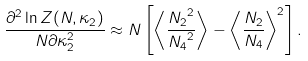Convert formula to latex. <formula><loc_0><loc_0><loc_500><loc_500>\frac { \partial ^ { 2 } \ln Z ( N , \kappa _ { 2 } ) } { N \partial \kappa _ { 2 } ^ { 2 } } \approx N \left [ \left \langle \frac { { N _ { 2 } } ^ { 2 } } { { N _ { 4 } } ^ { 2 } } \right \rangle - \left \langle \frac { N _ { 2 } } { N _ { 4 } } \right \rangle ^ { 2 } \right ] .</formula> 